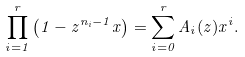<formula> <loc_0><loc_0><loc_500><loc_500>\prod _ { i = 1 } ^ { r } \left ( 1 - z ^ { n _ { i } - 1 } x \right ) = \sum _ { i = 0 } ^ { r } A _ { i } ( z ) x ^ { i } .</formula> 